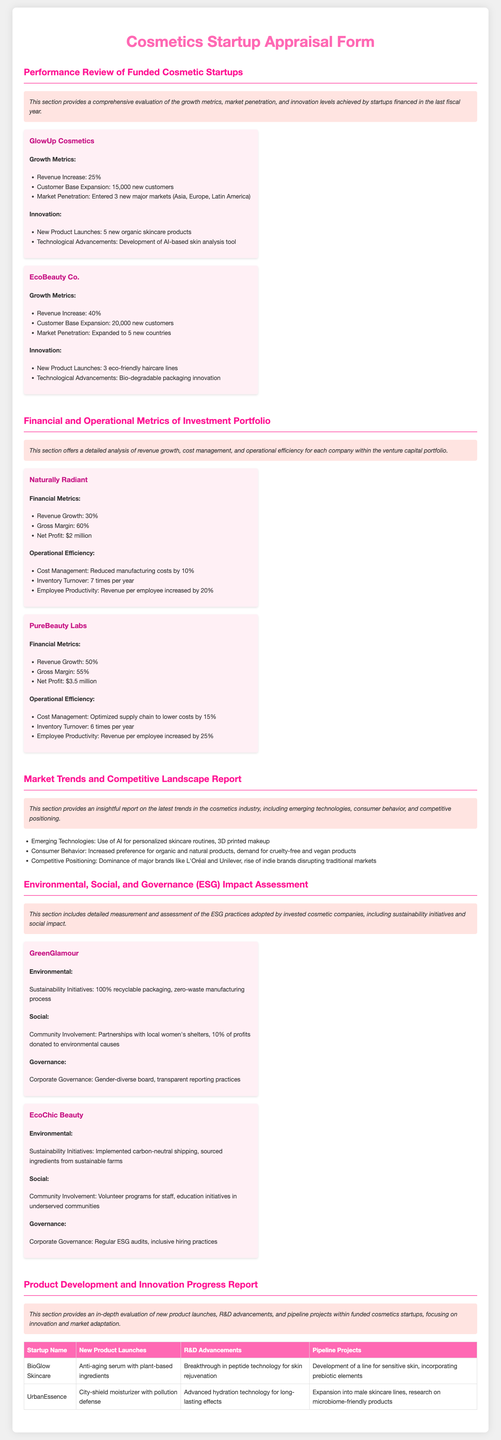what was the revenue increase for EcoBeauty Co.? The revenue increase for EcoBeauty Co. is a specific metric mentioned in the performance review section, quantified at 40%.
Answer: 40% how many new customers did GlowUp Cosmetics gain? The document indicates that GlowUp Cosmetics expanded its customer base by a defined number reported in the performance review, which is 15,000 new customers.
Answer: 15,000 what is the gross margin for PureBeauty Labs? The gross margin for PureBeauty Labs is detailed in the financial metrics section, stated as 55%.
Answer: 55% which startup launched an anti-aging serum with plant-based ingredients? The new product launches are listed in the product development section, and BioGlow Skincare's product is identified as the anti-aging serum with plant-based ingredients.
Answer: BioGlow Skincare what was GreenGlamour's sustainability initiative regarding packaging? The document highlights GreenGlamour's environmental practices by specifying that their sustainability initiative includes 100% recyclable packaging.
Answer: 100% recyclable packaging how many new markets did GlowUp Cosmetics enter? GlowUp Cosmetics’ market penetration is specified in the performance review section, mentioning entry into 3 new major markets.
Answer: 3 what innovative technology did EcoBeauty Co. develop? EcoBeauty Co. is noted for its technological advancements, specifically mentioning the bio-degradable packaging innovation in the performance review section.
Answer: Bio-degradable packaging innovation which company reported revenue growth of 30%? The financial metrics section of the document states that Naturally Radiant reported a revenue growth of 30%.
Answer: Naturally Radiant how many new countries did EcoBeauty Co. expand to? The performance review section lists EcoBeauty Co.'s market expansion to 5 new countries.
Answer: 5 